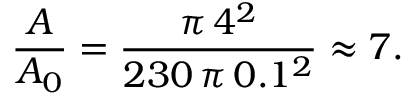<formula> <loc_0><loc_0><loc_500><loc_500>\frac { A } { A _ { 0 } } = \frac { \pi \, 4 ^ { 2 } } { 2 3 0 \, \pi \, 0 . 1 ^ { 2 } } \approx 7 .</formula> 